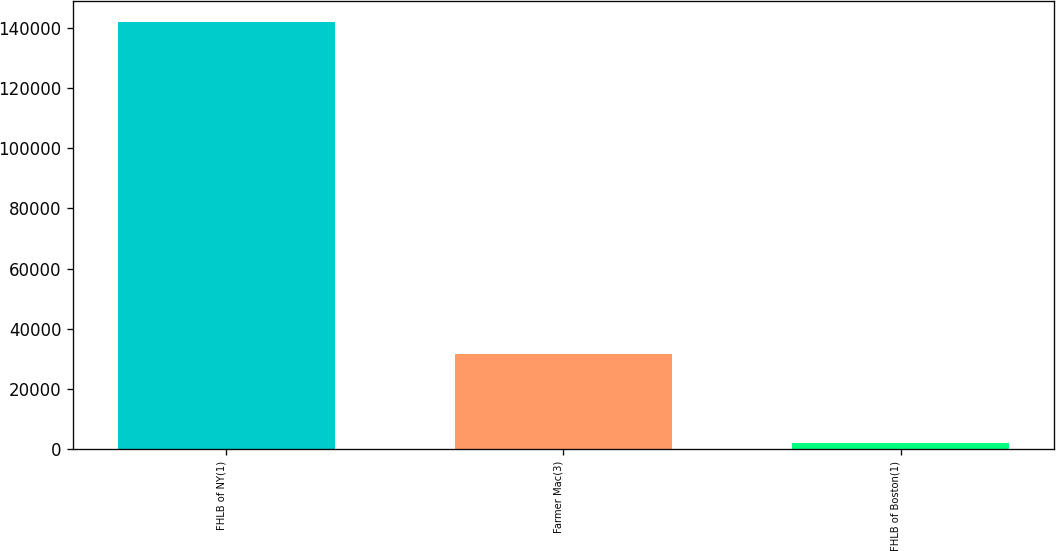Convert chart. <chart><loc_0><loc_0><loc_500><loc_500><bar_chart><fcel>FHLB of NY(1)<fcel>Farmer Mac(3)<fcel>FHLB of Boston(1)<nl><fcel>142042<fcel>31594<fcel>2112<nl></chart> 